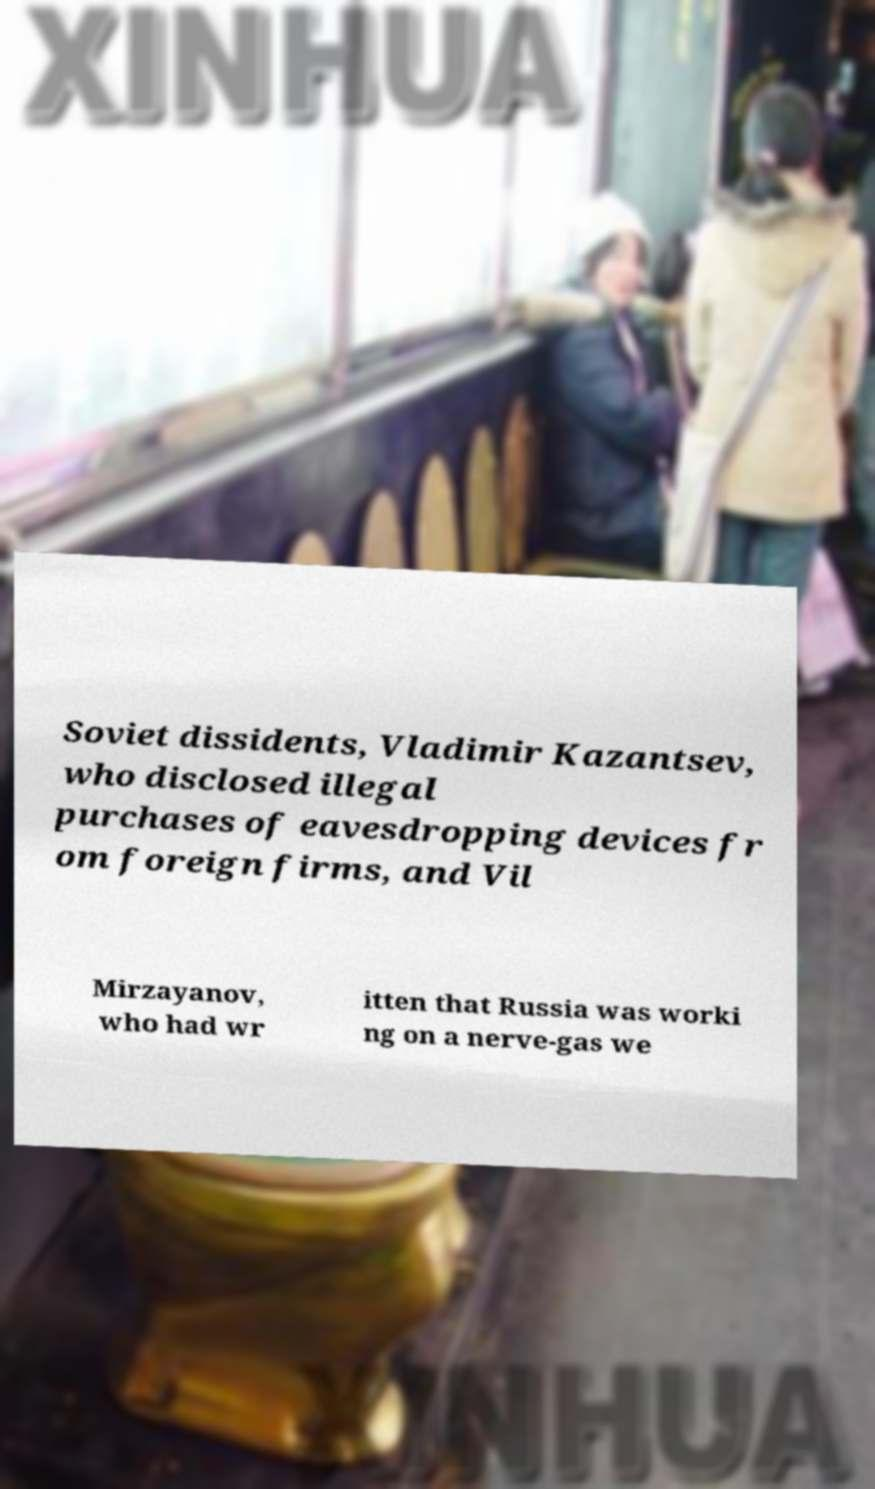Can you read and provide the text displayed in the image?This photo seems to have some interesting text. Can you extract and type it out for me? Soviet dissidents, Vladimir Kazantsev, who disclosed illegal purchases of eavesdropping devices fr om foreign firms, and Vil Mirzayanov, who had wr itten that Russia was worki ng on a nerve-gas we 